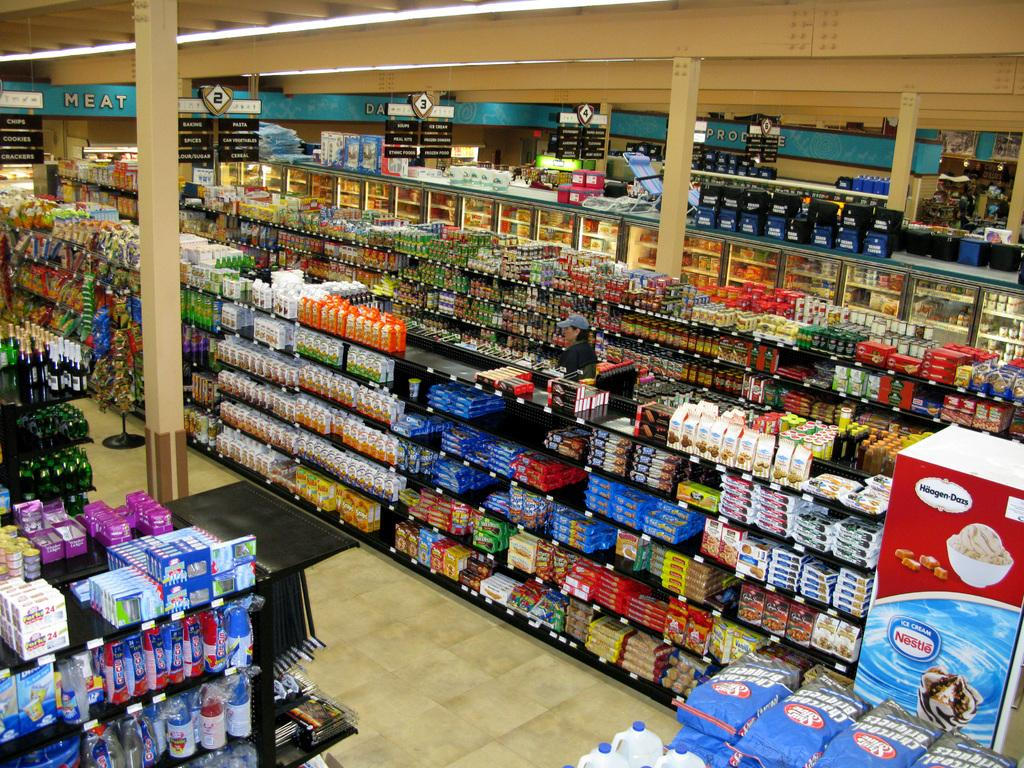What type of establishment is shown in the image? There is a supermarket in the image. What feature of the supermarket is mentioned in the facts? The supermarket has racks. What can be found on the racks in the supermarket? The racks contain different types of items. What is the color of the floor in the supermarket? The floor of the supermarket is in cream color. Can you see the porter carrying a car in the supermarket? There is no porter or car present in the image. 